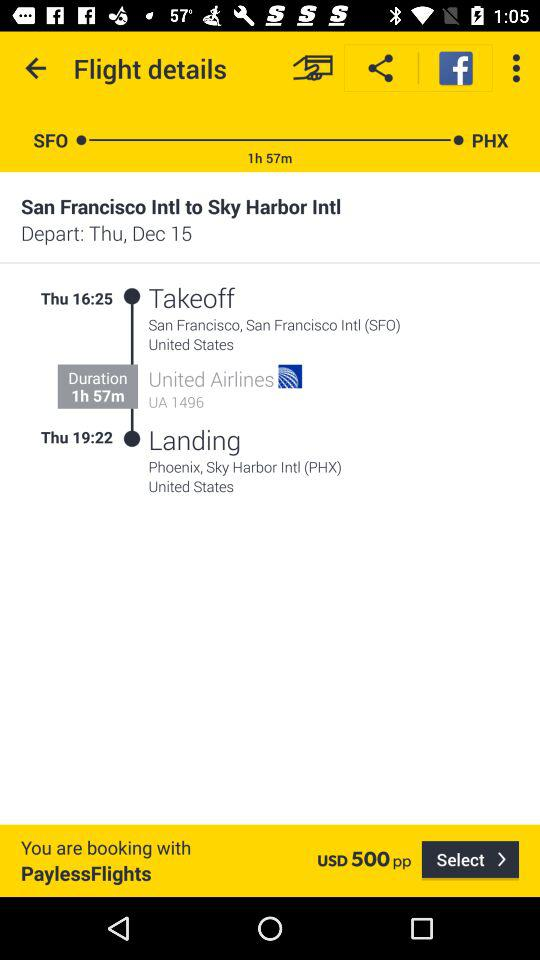What is the departure date? The departure date is Thursday, December 15. 